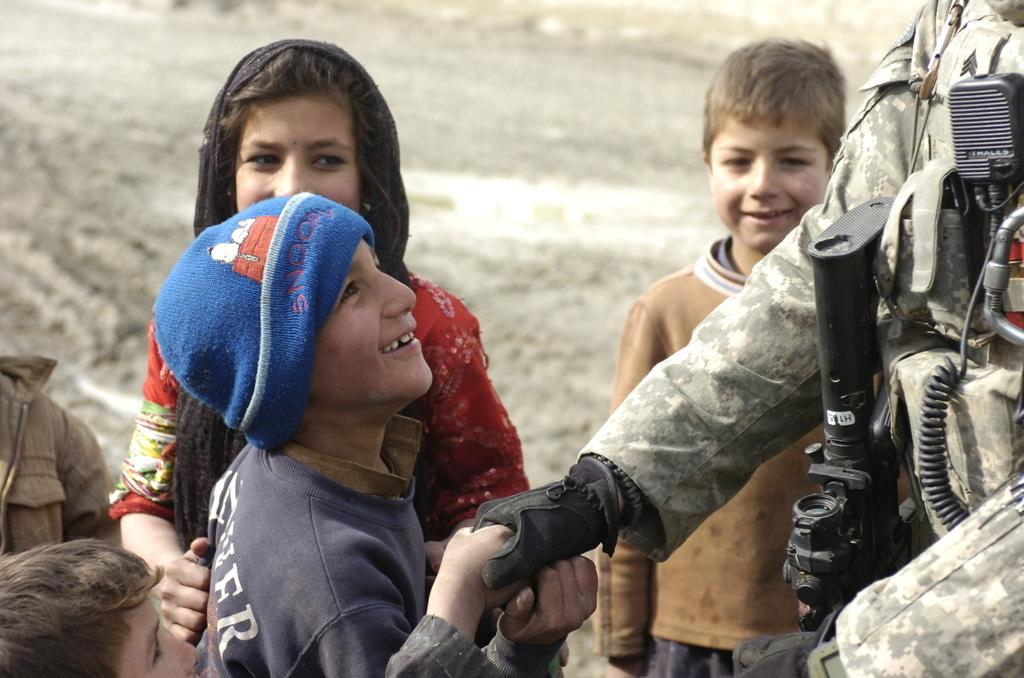How many people are in the image? The number of people in the image cannot be determined from the provided facts. What are the people doing in the image? The provided facts do not specify what the people are doing in the image. What is the surface on which the people are standing? The people are standing on the ground. How many snails can be seen crawling on the crate in the image? There is no crate or snails present in the image. 